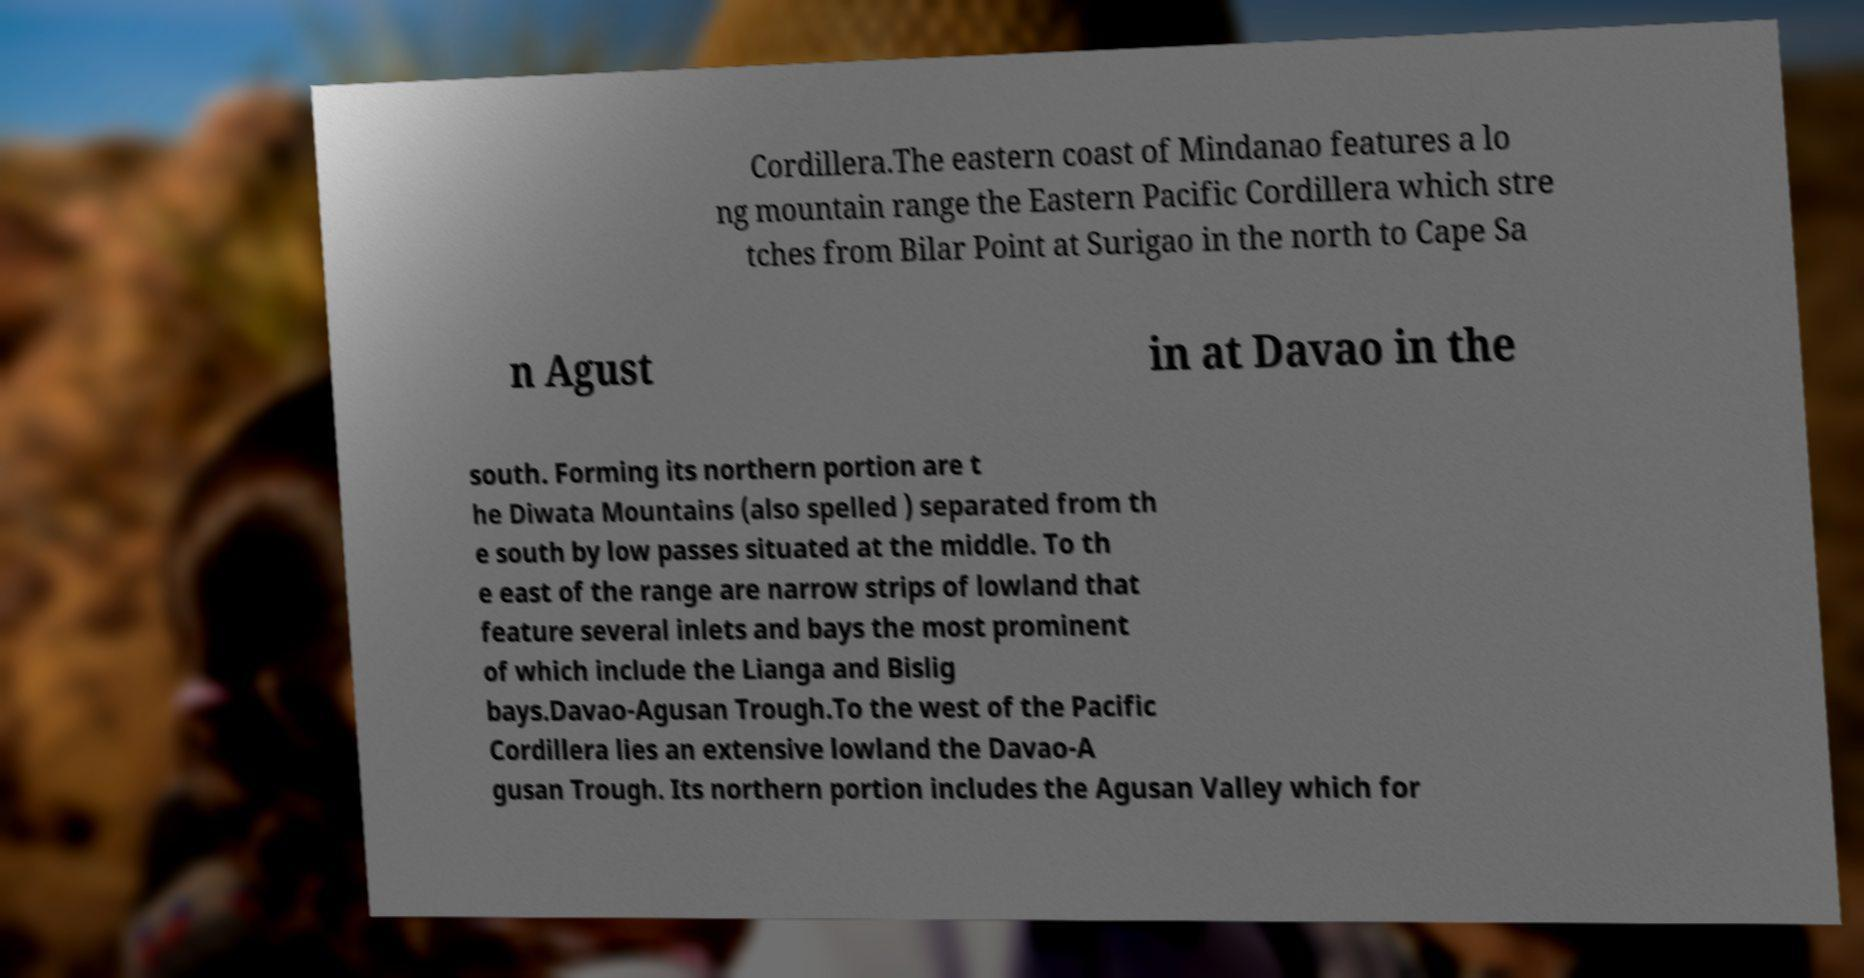Could you assist in decoding the text presented in this image and type it out clearly? Cordillera.The eastern coast of Mindanao features a lo ng mountain range the Eastern Pacific Cordillera which stre tches from Bilar Point at Surigao in the north to Cape Sa n Agust in at Davao in the south. Forming its northern portion are t he Diwata Mountains (also spelled ) separated from th e south by low passes situated at the middle. To th e east of the range are narrow strips of lowland that feature several inlets and bays the most prominent of which include the Lianga and Bislig bays.Davao-Agusan Trough.To the west of the Pacific Cordillera lies an extensive lowland the Davao-A gusan Trough. Its northern portion includes the Agusan Valley which for 